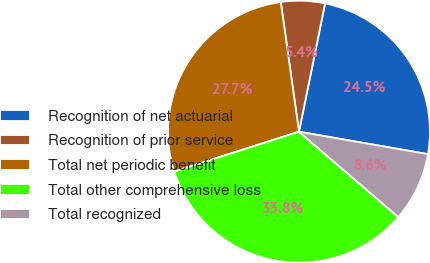<chart> <loc_0><loc_0><loc_500><loc_500><pie_chart><fcel>Recognition of net actuarial<fcel>Recognition of prior service<fcel>Total net periodic benefit<fcel>Total other comprehensive loss<fcel>Total recognized<nl><fcel>24.55%<fcel>5.41%<fcel>27.7%<fcel>33.78%<fcel>8.56%<nl></chart> 